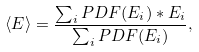<formula> <loc_0><loc_0><loc_500><loc_500>\langle E \rangle = \frac { \sum _ { i } P D F ( E _ { i } ) * E _ { i } } { \sum _ { i } P D F ( E _ { i } ) } ,</formula> 